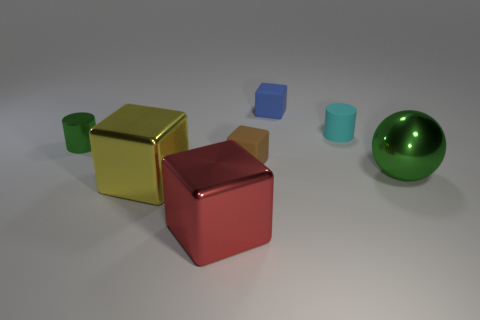Add 1 small shiny cylinders. How many objects exist? 8 Subtract all cubes. How many objects are left? 3 Add 5 green cylinders. How many green cylinders exist? 6 Subtract 0 brown balls. How many objects are left? 7 Subtract all green shiny things. Subtract all cyan objects. How many objects are left? 4 Add 1 red things. How many red things are left? 2 